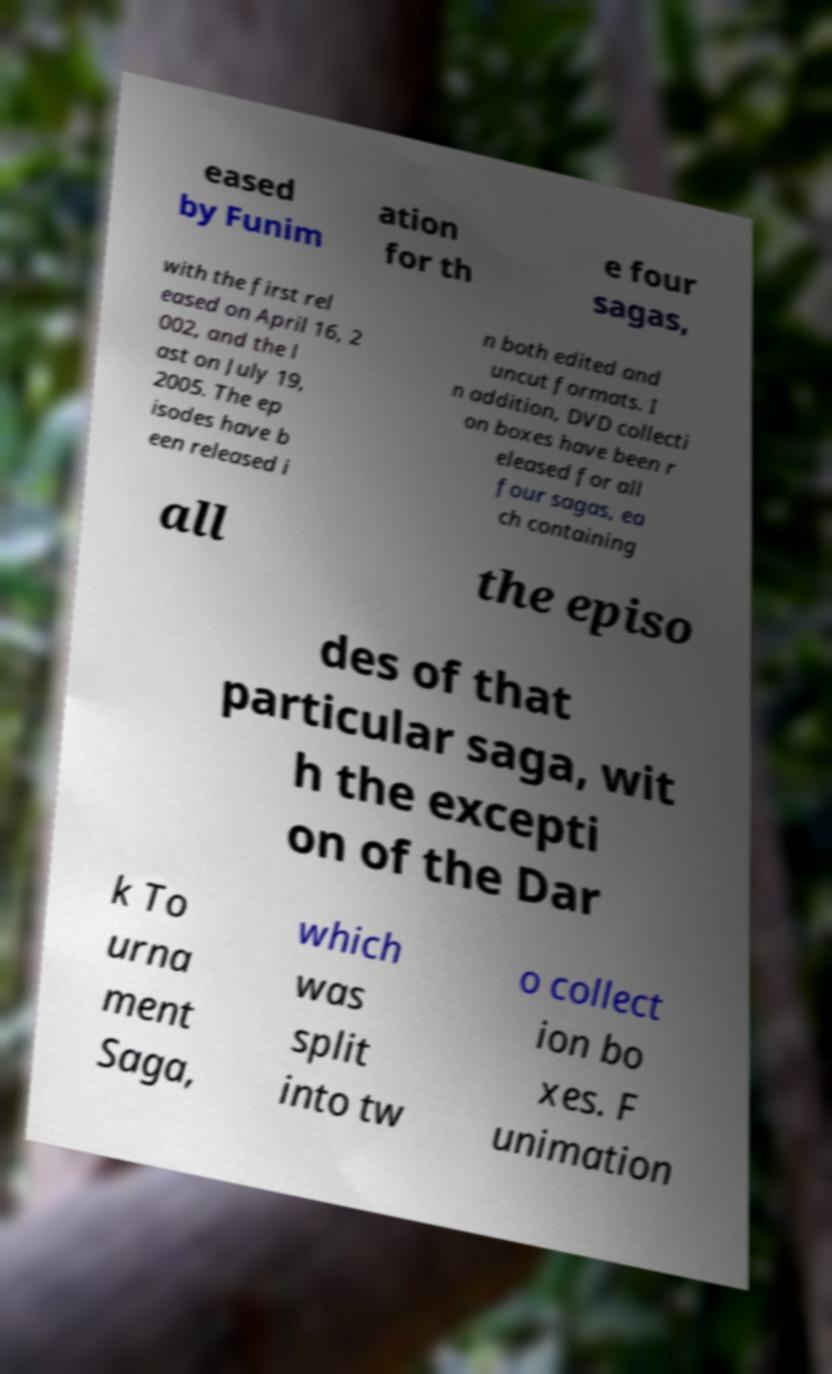I need the written content from this picture converted into text. Can you do that? eased by Funim ation for th e four sagas, with the first rel eased on April 16, 2 002, and the l ast on July 19, 2005. The ep isodes have b een released i n both edited and uncut formats. I n addition, DVD collecti on boxes have been r eleased for all four sagas, ea ch containing all the episo des of that particular saga, wit h the excepti on of the Dar k To urna ment Saga, which was split into tw o collect ion bo xes. F unimation 